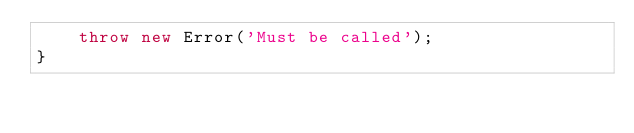<code> <loc_0><loc_0><loc_500><loc_500><_TypeScript_>    throw new Error('Must be called');
}</code> 